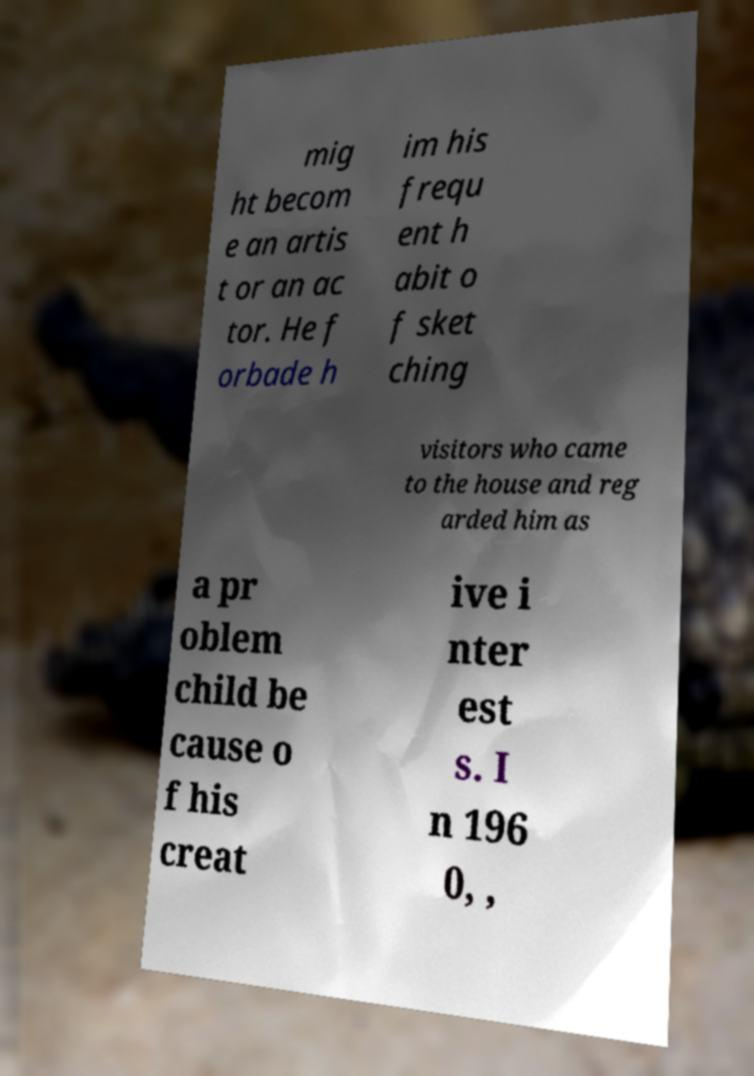Could you extract and type out the text from this image? mig ht becom e an artis t or an ac tor. He f orbade h im his frequ ent h abit o f sket ching visitors who came to the house and reg arded him as a pr oblem child be cause o f his creat ive i nter est s. I n 196 0, , 